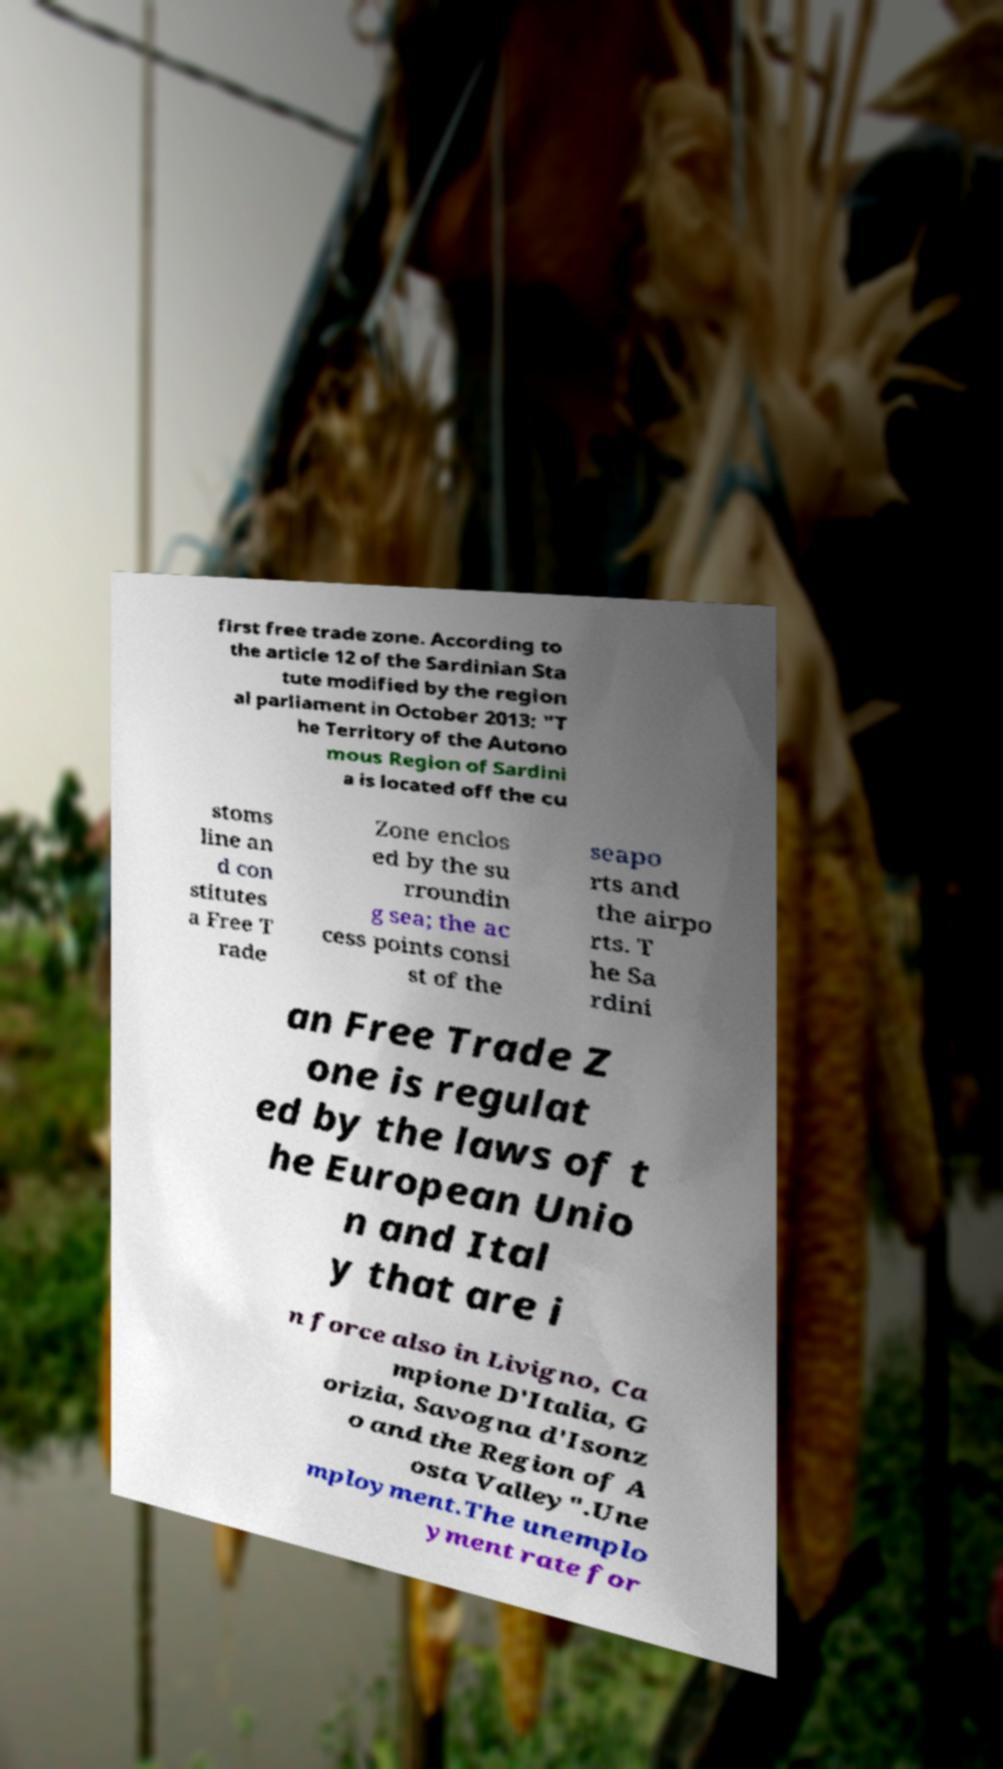Could you extract and type out the text from this image? first free trade zone. According to the article 12 of the Sardinian Sta tute modified by the region al parliament in October 2013: "T he Territory of the Autono mous Region of Sardini a is located off the cu stoms line an d con stitutes a Free T rade Zone enclos ed by the su rroundin g sea; the ac cess points consi st of the seapo rts and the airpo rts. T he Sa rdini an Free Trade Z one is regulat ed by the laws of t he European Unio n and Ital y that are i n force also in Livigno, Ca mpione D'Italia, G orizia, Savogna d'Isonz o and the Region of A osta Valley".Une mployment.The unemplo yment rate for 